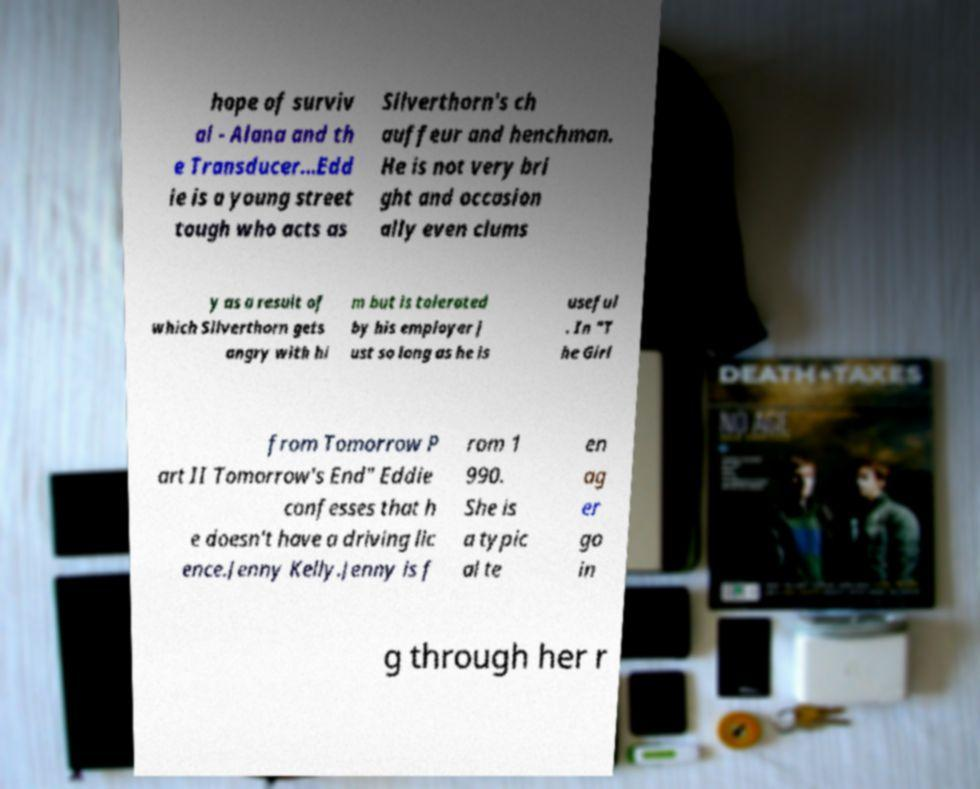Can you accurately transcribe the text from the provided image for me? hope of surviv al - Alana and th e Transducer...Edd ie is a young street tough who acts as Silverthorn's ch auffeur and henchman. He is not very bri ght and occasion ally even clums y as a result of which Silverthorn gets angry with hi m but is tolerated by his employer j ust so long as he is useful . In "T he Girl from Tomorrow P art II Tomorrow's End" Eddie confesses that h e doesn't have a driving lic ence.Jenny Kelly.Jenny is f rom 1 990. She is a typic al te en ag er go in g through her r 